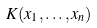Convert formula to latex. <formula><loc_0><loc_0><loc_500><loc_500>K ( x _ { 1 } , \dots , x _ { n } )</formula> 